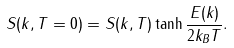<formula> <loc_0><loc_0><loc_500><loc_500>S ( k , T = 0 ) = S ( k , T ) \tanh { \frac { E ( k ) } { 2 k _ { B } T } } .</formula> 